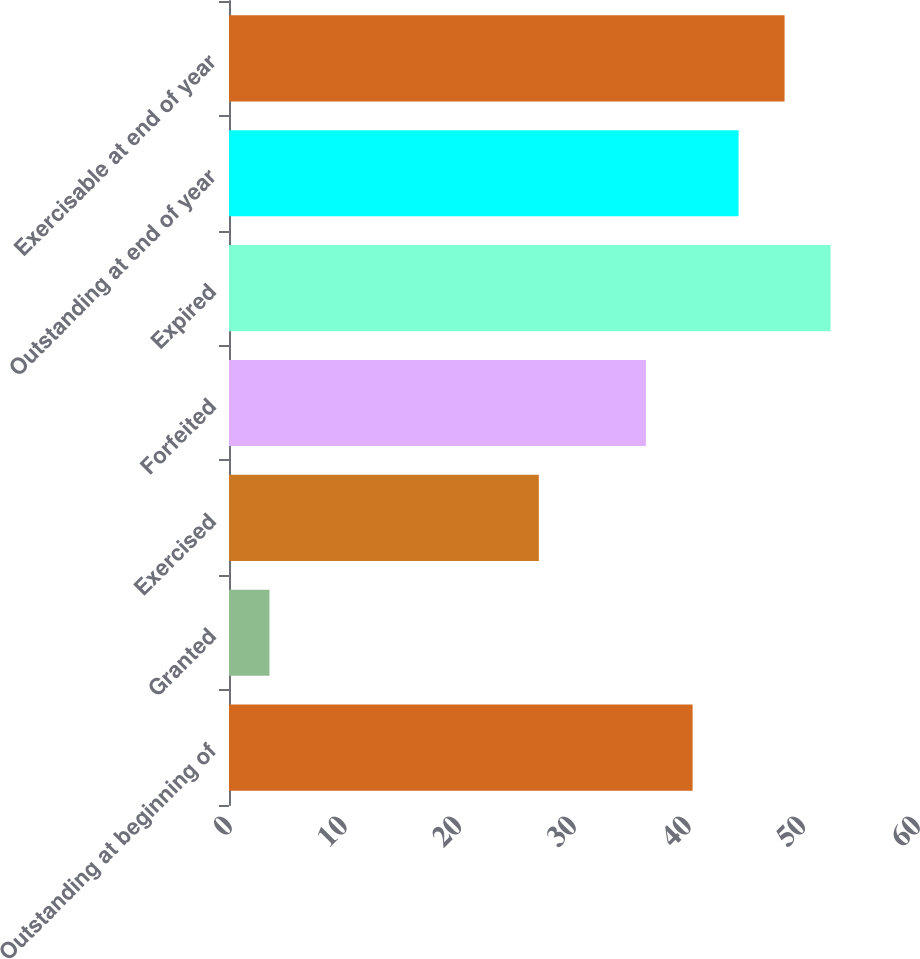Convert chart to OTSL. <chart><loc_0><loc_0><loc_500><loc_500><bar_chart><fcel>Outstanding at beginning of<fcel>Granted<fcel>Exercised<fcel>Forfeited<fcel>Expired<fcel>Outstanding at end of year<fcel>Exercisable at end of year<nl><fcel>40.43<fcel>3.53<fcel>27.02<fcel>36.36<fcel>52.46<fcel>44.44<fcel>48.45<nl></chart> 